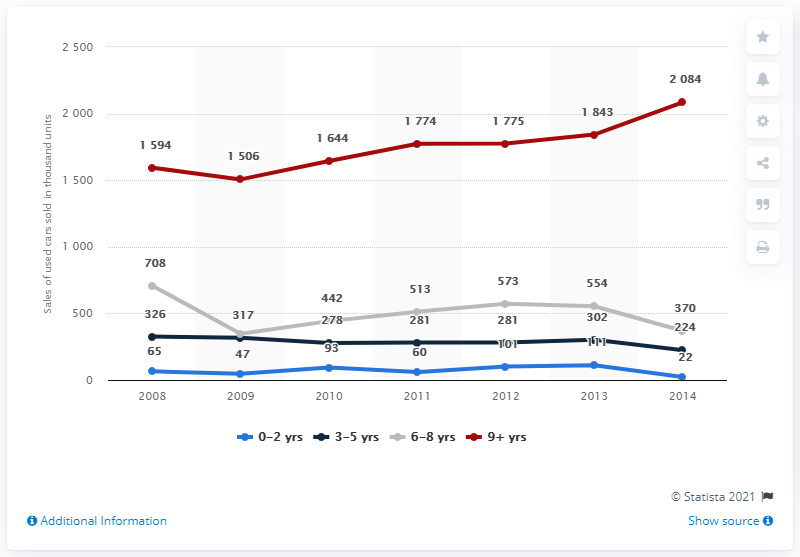Draw attention to some important aspects in this diagram. The age category represented in red is 9 years old or older. In 2014, the total value was approximately 2700. 